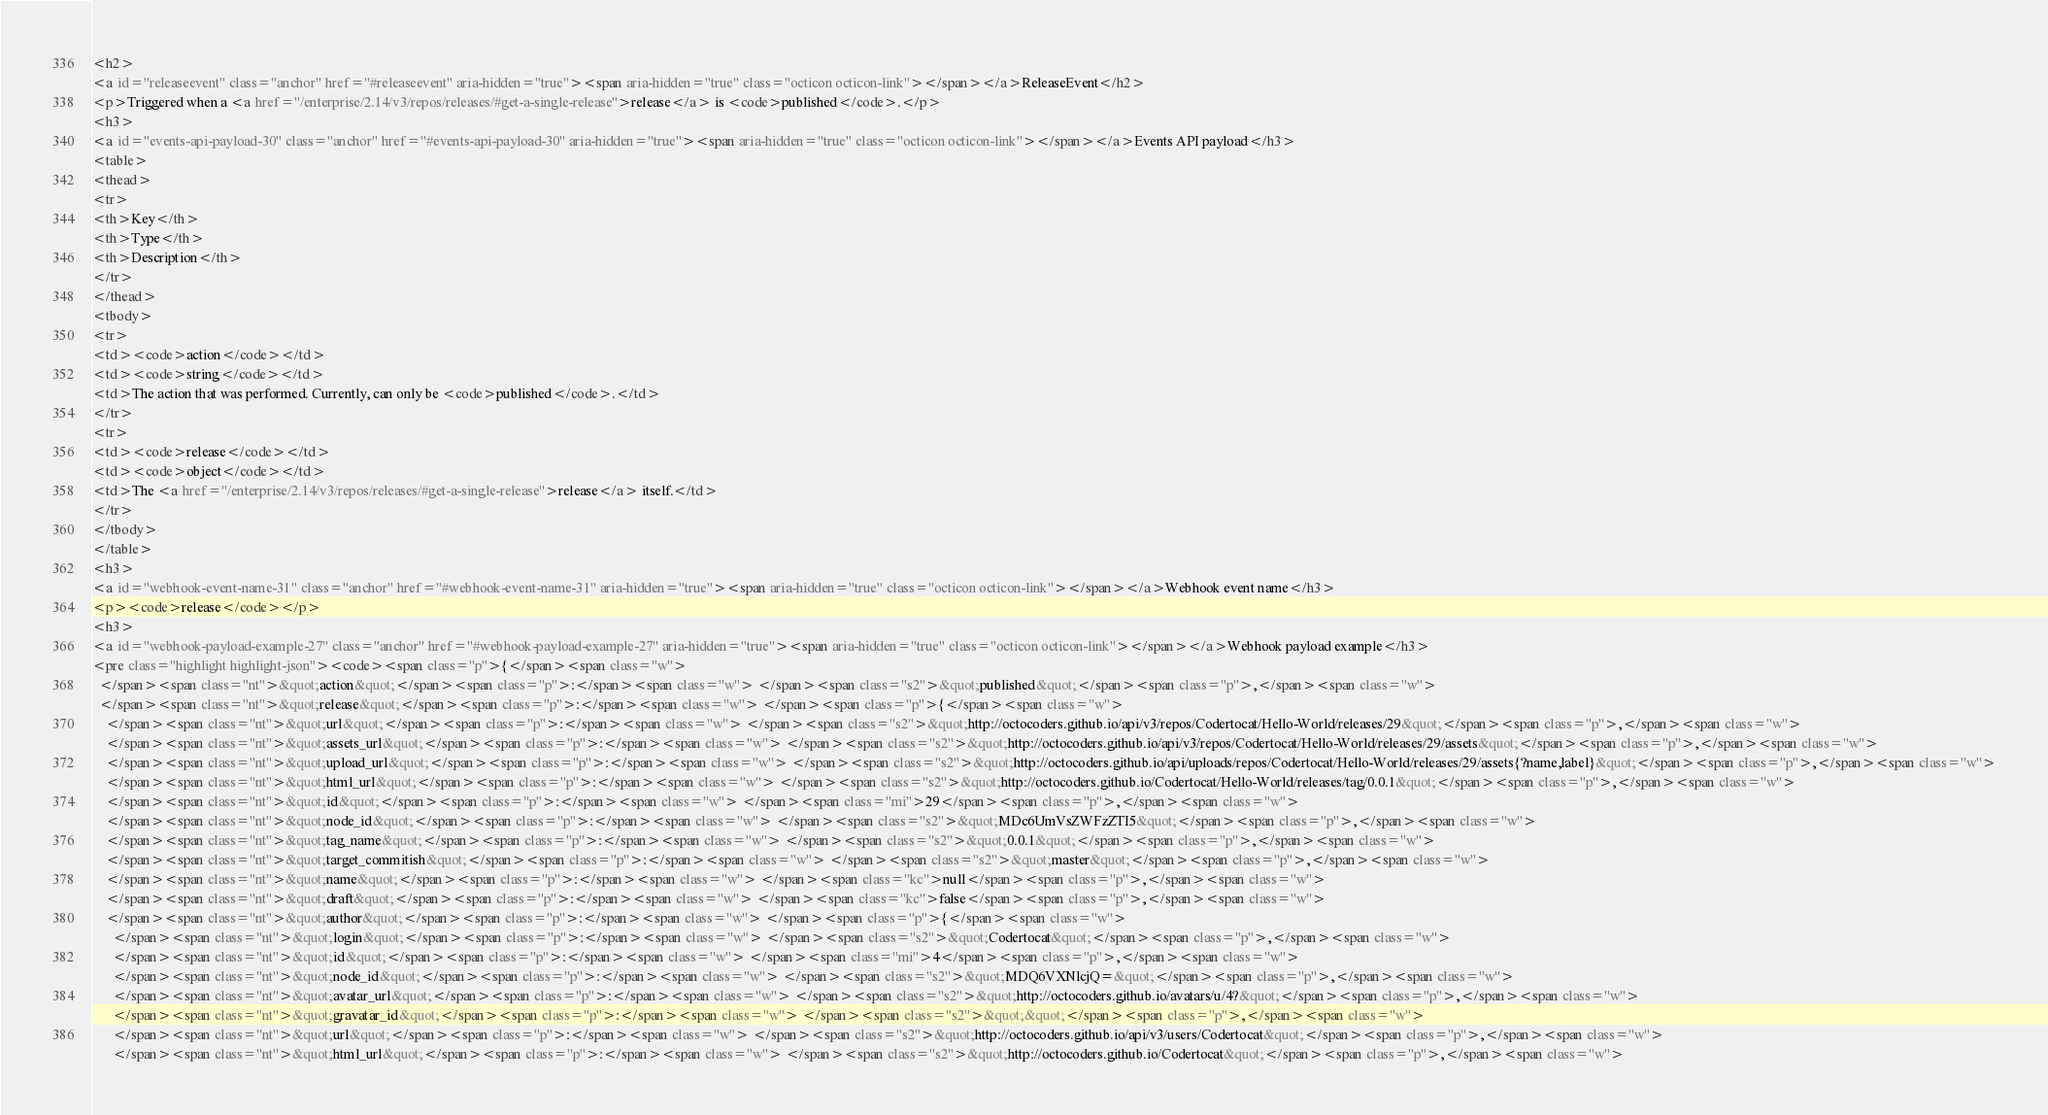<code> <loc_0><loc_0><loc_500><loc_500><_HTML_><h2>
<a id="releaseevent" class="anchor" href="#releaseevent" aria-hidden="true"><span aria-hidden="true" class="octicon octicon-link"></span></a>ReleaseEvent</h2>
<p>Triggered when a <a href="/enterprise/2.14/v3/repos/releases/#get-a-single-release">release</a> is <code>published</code>.</p>
<h3>
<a id="events-api-payload-30" class="anchor" href="#events-api-payload-30" aria-hidden="true"><span aria-hidden="true" class="octicon octicon-link"></span></a>Events API payload</h3>
<table>
<thead>
<tr>
<th>Key</th>
<th>Type</th>
<th>Description</th>
</tr>
</thead>
<tbody>
<tr>
<td><code>action</code></td>
<td><code>string</code></td>
<td>The action that was performed. Currently, can only be <code>published</code>.</td>
</tr>
<tr>
<td><code>release</code></td>
<td><code>object</code></td>
<td>The <a href="/enterprise/2.14/v3/repos/releases/#get-a-single-release">release</a> itself.</td>
</tr>
</tbody>
</table>
<h3>
<a id="webhook-event-name-31" class="anchor" href="#webhook-event-name-31" aria-hidden="true"><span aria-hidden="true" class="octicon octicon-link"></span></a>Webhook event name</h3>
<p><code>release</code></p>
<h3>
<a id="webhook-payload-example-27" class="anchor" href="#webhook-payload-example-27" aria-hidden="true"><span aria-hidden="true" class="octicon octicon-link"></span></a>Webhook payload example</h3>
<pre class="highlight highlight-json"><code><span class="p">{</span><span class="w">
  </span><span class="nt">&quot;action&quot;</span><span class="p">:</span><span class="w"> </span><span class="s2">&quot;published&quot;</span><span class="p">,</span><span class="w">
  </span><span class="nt">&quot;release&quot;</span><span class="p">:</span><span class="w"> </span><span class="p">{</span><span class="w">
    </span><span class="nt">&quot;url&quot;</span><span class="p">:</span><span class="w"> </span><span class="s2">&quot;http://octocoders.github.io/api/v3/repos/Codertocat/Hello-World/releases/29&quot;</span><span class="p">,</span><span class="w">
    </span><span class="nt">&quot;assets_url&quot;</span><span class="p">:</span><span class="w"> </span><span class="s2">&quot;http://octocoders.github.io/api/v3/repos/Codertocat/Hello-World/releases/29/assets&quot;</span><span class="p">,</span><span class="w">
    </span><span class="nt">&quot;upload_url&quot;</span><span class="p">:</span><span class="w"> </span><span class="s2">&quot;http://octocoders.github.io/api/uploads/repos/Codertocat/Hello-World/releases/29/assets{?name,label}&quot;</span><span class="p">,</span><span class="w">
    </span><span class="nt">&quot;html_url&quot;</span><span class="p">:</span><span class="w"> </span><span class="s2">&quot;http://octocoders.github.io/Codertocat/Hello-World/releases/tag/0.0.1&quot;</span><span class="p">,</span><span class="w">
    </span><span class="nt">&quot;id&quot;</span><span class="p">:</span><span class="w"> </span><span class="mi">29</span><span class="p">,</span><span class="w">
    </span><span class="nt">&quot;node_id&quot;</span><span class="p">:</span><span class="w"> </span><span class="s2">&quot;MDc6UmVsZWFzZTI5&quot;</span><span class="p">,</span><span class="w">
    </span><span class="nt">&quot;tag_name&quot;</span><span class="p">:</span><span class="w"> </span><span class="s2">&quot;0.0.1&quot;</span><span class="p">,</span><span class="w">
    </span><span class="nt">&quot;target_commitish&quot;</span><span class="p">:</span><span class="w"> </span><span class="s2">&quot;master&quot;</span><span class="p">,</span><span class="w">
    </span><span class="nt">&quot;name&quot;</span><span class="p">:</span><span class="w"> </span><span class="kc">null</span><span class="p">,</span><span class="w">
    </span><span class="nt">&quot;draft&quot;</span><span class="p">:</span><span class="w"> </span><span class="kc">false</span><span class="p">,</span><span class="w">
    </span><span class="nt">&quot;author&quot;</span><span class="p">:</span><span class="w"> </span><span class="p">{</span><span class="w">
      </span><span class="nt">&quot;login&quot;</span><span class="p">:</span><span class="w"> </span><span class="s2">&quot;Codertocat&quot;</span><span class="p">,</span><span class="w">
      </span><span class="nt">&quot;id&quot;</span><span class="p">:</span><span class="w"> </span><span class="mi">4</span><span class="p">,</span><span class="w">
      </span><span class="nt">&quot;node_id&quot;</span><span class="p">:</span><span class="w"> </span><span class="s2">&quot;MDQ6VXNlcjQ=&quot;</span><span class="p">,</span><span class="w">
      </span><span class="nt">&quot;avatar_url&quot;</span><span class="p">:</span><span class="w"> </span><span class="s2">&quot;http://octocoders.github.io/avatars/u/4?&quot;</span><span class="p">,</span><span class="w">
      </span><span class="nt">&quot;gravatar_id&quot;</span><span class="p">:</span><span class="w"> </span><span class="s2">&quot;&quot;</span><span class="p">,</span><span class="w">
      </span><span class="nt">&quot;url&quot;</span><span class="p">:</span><span class="w"> </span><span class="s2">&quot;http://octocoders.github.io/api/v3/users/Codertocat&quot;</span><span class="p">,</span><span class="w">
      </span><span class="nt">&quot;html_url&quot;</span><span class="p">:</span><span class="w"> </span><span class="s2">&quot;http://octocoders.github.io/Codertocat&quot;</span><span class="p">,</span><span class="w"></code> 